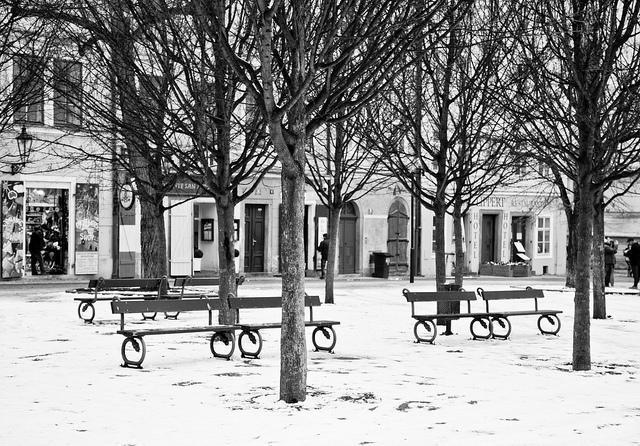How many inches of snow would you guess are on the ground?
Give a very brief answer. 1. How many benches are there?
Give a very brief answer. 6. How many benches are visible?
Give a very brief answer. 4. How many plastic white forks can you count?
Give a very brief answer. 0. 